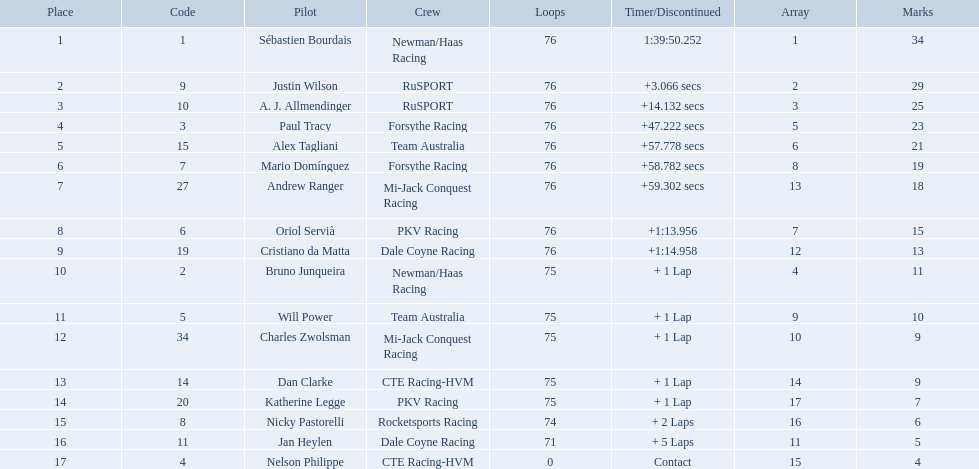What drivers took part in the 2006 tecate grand prix of monterrey? Sébastien Bourdais, Justin Wilson, A. J. Allmendinger, Paul Tracy, Alex Tagliani, Mario Domínguez, Andrew Ranger, Oriol Servià, Cristiano da Matta, Bruno Junqueira, Will Power, Charles Zwolsman, Dan Clarke, Katherine Legge, Nicky Pastorelli, Jan Heylen, Nelson Philippe. Which of those drivers scored the same amount of points as another driver? Charles Zwolsman, Dan Clarke. Who had the same amount of points as charles zwolsman? Dan Clarke. What was alex taglini's final score in the tecate grand prix? 21. What was paul tracy's final score in the tecate grand prix? 23. Which driver finished first? Paul Tracy. 